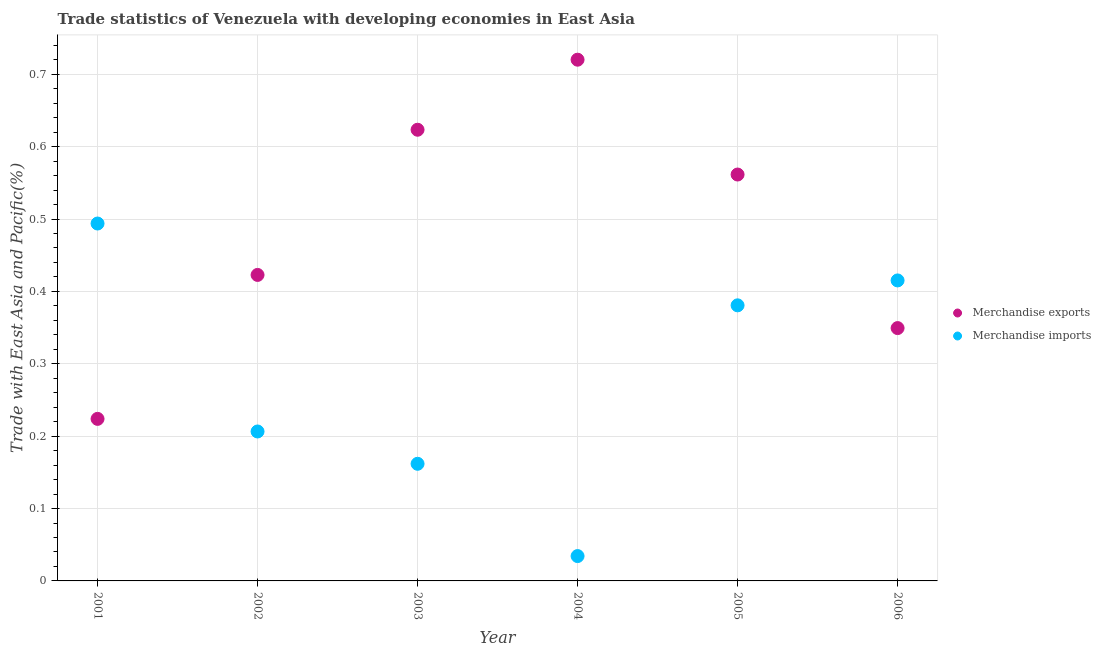Is the number of dotlines equal to the number of legend labels?
Ensure brevity in your answer.  Yes. What is the merchandise exports in 2004?
Offer a very short reply. 0.72. Across all years, what is the maximum merchandise imports?
Your answer should be compact. 0.49. Across all years, what is the minimum merchandise imports?
Provide a short and direct response. 0.03. In which year was the merchandise exports minimum?
Keep it short and to the point. 2001. What is the total merchandise exports in the graph?
Your answer should be compact. 2.9. What is the difference between the merchandise exports in 2002 and that in 2004?
Offer a terse response. -0.3. What is the difference between the merchandise exports in 2003 and the merchandise imports in 2006?
Ensure brevity in your answer.  0.21. What is the average merchandise exports per year?
Ensure brevity in your answer.  0.48. In the year 2002, what is the difference between the merchandise exports and merchandise imports?
Your answer should be very brief. 0.22. In how many years, is the merchandise imports greater than 0.16 %?
Your answer should be compact. 5. What is the ratio of the merchandise imports in 2001 to that in 2005?
Offer a very short reply. 1.3. Is the merchandise imports in 2002 less than that in 2006?
Provide a short and direct response. Yes. Is the difference between the merchandise exports in 2004 and 2005 greater than the difference between the merchandise imports in 2004 and 2005?
Keep it short and to the point. Yes. What is the difference between the highest and the second highest merchandise exports?
Offer a very short reply. 0.1. What is the difference between the highest and the lowest merchandise exports?
Your response must be concise. 0.5. Is the sum of the merchandise exports in 2002 and 2003 greater than the maximum merchandise imports across all years?
Ensure brevity in your answer.  Yes. Is the merchandise exports strictly less than the merchandise imports over the years?
Offer a very short reply. No. How many dotlines are there?
Give a very brief answer. 2. What is the difference between two consecutive major ticks on the Y-axis?
Your answer should be compact. 0.1. Are the values on the major ticks of Y-axis written in scientific E-notation?
Provide a succinct answer. No. How are the legend labels stacked?
Provide a succinct answer. Vertical. What is the title of the graph?
Offer a terse response. Trade statistics of Venezuela with developing economies in East Asia. What is the label or title of the Y-axis?
Provide a short and direct response. Trade with East Asia and Pacific(%). What is the Trade with East Asia and Pacific(%) in Merchandise exports in 2001?
Provide a succinct answer. 0.22. What is the Trade with East Asia and Pacific(%) of Merchandise imports in 2001?
Make the answer very short. 0.49. What is the Trade with East Asia and Pacific(%) of Merchandise exports in 2002?
Keep it short and to the point. 0.42. What is the Trade with East Asia and Pacific(%) in Merchandise imports in 2002?
Give a very brief answer. 0.21. What is the Trade with East Asia and Pacific(%) in Merchandise exports in 2003?
Your answer should be compact. 0.62. What is the Trade with East Asia and Pacific(%) of Merchandise imports in 2003?
Ensure brevity in your answer.  0.16. What is the Trade with East Asia and Pacific(%) of Merchandise exports in 2004?
Your answer should be compact. 0.72. What is the Trade with East Asia and Pacific(%) of Merchandise imports in 2004?
Your answer should be very brief. 0.03. What is the Trade with East Asia and Pacific(%) in Merchandise exports in 2005?
Keep it short and to the point. 0.56. What is the Trade with East Asia and Pacific(%) in Merchandise imports in 2005?
Your response must be concise. 0.38. What is the Trade with East Asia and Pacific(%) of Merchandise exports in 2006?
Your response must be concise. 0.35. What is the Trade with East Asia and Pacific(%) in Merchandise imports in 2006?
Offer a very short reply. 0.42. Across all years, what is the maximum Trade with East Asia and Pacific(%) of Merchandise exports?
Provide a short and direct response. 0.72. Across all years, what is the maximum Trade with East Asia and Pacific(%) of Merchandise imports?
Offer a very short reply. 0.49. Across all years, what is the minimum Trade with East Asia and Pacific(%) in Merchandise exports?
Your answer should be compact. 0.22. Across all years, what is the minimum Trade with East Asia and Pacific(%) of Merchandise imports?
Offer a terse response. 0.03. What is the total Trade with East Asia and Pacific(%) of Merchandise exports in the graph?
Offer a very short reply. 2.9. What is the total Trade with East Asia and Pacific(%) in Merchandise imports in the graph?
Make the answer very short. 1.69. What is the difference between the Trade with East Asia and Pacific(%) in Merchandise exports in 2001 and that in 2002?
Give a very brief answer. -0.2. What is the difference between the Trade with East Asia and Pacific(%) in Merchandise imports in 2001 and that in 2002?
Your response must be concise. 0.29. What is the difference between the Trade with East Asia and Pacific(%) of Merchandise exports in 2001 and that in 2003?
Ensure brevity in your answer.  -0.4. What is the difference between the Trade with East Asia and Pacific(%) in Merchandise imports in 2001 and that in 2003?
Make the answer very short. 0.33. What is the difference between the Trade with East Asia and Pacific(%) in Merchandise exports in 2001 and that in 2004?
Offer a terse response. -0.5. What is the difference between the Trade with East Asia and Pacific(%) in Merchandise imports in 2001 and that in 2004?
Your answer should be compact. 0.46. What is the difference between the Trade with East Asia and Pacific(%) in Merchandise exports in 2001 and that in 2005?
Keep it short and to the point. -0.34. What is the difference between the Trade with East Asia and Pacific(%) of Merchandise imports in 2001 and that in 2005?
Ensure brevity in your answer.  0.11. What is the difference between the Trade with East Asia and Pacific(%) in Merchandise exports in 2001 and that in 2006?
Keep it short and to the point. -0.13. What is the difference between the Trade with East Asia and Pacific(%) in Merchandise imports in 2001 and that in 2006?
Offer a terse response. 0.08. What is the difference between the Trade with East Asia and Pacific(%) in Merchandise exports in 2002 and that in 2003?
Provide a succinct answer. -0.2. What is the difference between the Trade with East Asia and Pacific(%) in Merchandise imports in 2002 and that in 2003?
Give a very brief answer. 0.04. What is the difference between the Trade with East Asia and Pacific(%) of Merchandise exports in 2002 and that in 2004?
Keep it short and to the point. -0.3. What is the difference between the Trade with East Asia and Pacific(%) of Merchandise imports in 2002 and that in 2004?
Your answer should be very brief. 0.17. What is the difference between the Trade with East Asia and Pacific(%) in Merchandise exports in 2002 and that in 2005?
Offer a terse response. -0.14. What is the difference between the Trade with East Asia and Pacific(%) of Merchandise imports in 2002 and that in 2005?
Keep it short and to the point. -0.17. What is the difference between the Trade with East Asia and Pacific(%) of Merchandise exports in 2002 and that in 2006?
Make the answer very short. 0.07. What is the difference between the Trade with East Asia and Pacific(%) in Merchandise imports in 2002 and that in 2006?
Offer a terse response. -0.21. What is the difference between the Trade with East Asia and Pacific(%) of Merchandise exports in 2003 and that in 2004?
Your response must be concise. -0.1. What is the difference between the Trade with East Asia and Pacific(%) of Merchandise imports in 2003 and that in 2004?
Your answer should be very brief. 0.13. What is the difference between the Trade with East Asia and Pacific(%) in Merchandise exports in 2003 and that in 2005?
Ensure brevity in your answer.  0.06. What is the difference between the Trade with East Asia and Pacific(%) in Merchandise imports in 2003 and that in 2005?
Make the answer very short. -0.22. What is the difference between the Trade with East Asia and Pacific(%) of Merchandise exports in 2003 and that in 2006?
Ensure brevity in your answer.  0.27. What is the difference between the Trade with East Asia and Pacific(%) of Merchandise imports in 2003 and that in 2006?
Make the answer very short. -0.25. What is the difference between the Trade with East Asia and Pacific(%) in Merchandise exports in 2004 and that in 2005?
Offer a terse response. 0.16. What is the difference between the Trade with East Asia and Pacific(%) in Merchandise imports in 2004 and that in 2005?
Give a very brief answer. -0.35. What is the difference between the Trade with East Asia and Pacific(%) of Merchandise exports in 2004 and that in 2006?
Ensure brevity in your answer.  0.37. What is the difference between the Trade with East Asia and Pacific(%) in Merchandise imports in 2004 and that in 2006?
Your answer should be compact. -0.38. What is the difference between the Trade with East Asia and Pacific(%) in Merchandise exports in 2005 and that in 2006?
Ensure brevity in your answer.  0.21. What is the difference between the Trade with East Asia and Pacific(%) of Merchandise imports in 2005 and that in 2006?
Your answer should be compact. -0.03. What is the difference between the Trade with East Asia and Pacific(%) in Merchandise exports in 2001 and the Trade with East Asia and Pacific(%) in Merchandise imports in 2002?
Give a very brief answer. 0.02. What is the difference between the Trade with East Asia and Pacific(%) of Merchandise exports in 2001 and the Trade with East Asia and Pacific(%) of Merchandise imports in 2003?
Offer a terse response. 0.06. What is the difference between the Trade with East Asia and Pacific(%) in Merchandise exports in 2001 and the Trade with East Asia and Pacific(%) in Merchandise imports in 2004?
Your response must be concise. 0.19. What is the difference between the Trade with East Asia and Pacific(%) of Merchandise exports in 2001 and the Trade with East Asia and Pacific(%) of Merchandise imports in 2005?
Keep it short and to the point. -0.16. What is the difference between the Trade with East Asia and Pacific(%) in Merchandise exports in 2001 and the Trade with East Asia and Pacific(%) in Merchandise imports in 2006?
Give a very brief answer. -0.19. What is the difference between the Trade with East Asia and Pacific(%) in Merchandise exports in 2002 and the Trade with East Asia and Pacific(%) in Merchandise imports in 2003?
Make the answer very short. 0.26. What is the difference between the Trade with East Asia and Pacific(%) of Merchandise exports in 2002 and the Trade with East Asia and Pacific(%) of Merchandise imports in 2004?
Ensure brevity in your answer.  0.39. What is the difference between the Trade with East Asia and Pacific(%) of Merchandise exports in 2002 and the Trade with East Asia and Pacific(%) of Merchandise imports in 2005?
Your answer should be compact. 0.04. What is the difference between the Trade with East Asia and Pacific(%) of Merchandise exports in 2002 and the Trade with East Asia and Pacific(%) of Merchandise imports in 2006?
Your answer should be very brief. 0.01. What is the difference between the Trade with East Asia and Pacific(%) of Merchandise exports in 2003 and the Trade with East Asia and Pacific(%) of Merchandise imports in 2004?
Ensure brevity in your answer.  0.59. What is the difference between the Trade with East Asia and Pacific(%) in Merchandise exports in 2003 and the Trade with East Asia and Pacific(%) in Merchandise imports in 2005?
Offer a very short reply. 0.24. What is the difference between the Trade with East Asia and Pacific(%) in Merchandise exports in 2003 and the Trade with East Asia and Pacific(%) in Merchandise imports in 2006?
Ensure brevity in your answer.  0.21. What is the difference between the Trade with East Asia and Pacific(%) in Merchandise exports in 2004 and the Trade with East Asia and Pacific(%) in Merchandise imports in 2005?
Your response must be concise. 0.34. What is the difference between the Trade with East Asia and Pacific(%) of Merchandise exports in 2004 and the Trade with East Asia and Pacific(%) of Merchandise imports in 2006?
Give a very brief answer. 0.3. What is the difference between the Trade with East Asia and Pacific(%) in Merchandise exports in 2005 and the Trade with East Asia and Pacific(%) in Merchandise imports in 2006?
Your response must be concise. 0.15. What is the average Trade with East Asia and Pacific(%) in Merchandise exports per year?
Ensure brevity in your answer.  0.48. What is the average Trade with East Asia and Pacific(%) of Merchandise imports per year?
Offer a terse response. 0.28. In the year 2001, what is the difference between the Trade with East Asia and Pacific(%) of Merchandise exports and Trade with East Asia and Pacific(%) of Merchandise imports?
Provide a short and direct response. -0.27. In the year 2002, what is the difference between the Trade with East Asia and Pacific(%) of Merchandise exports and Trade with East Asia and Pacific(%) of Merchandise imports?
Your response must be concise. 0.22. In the year 2003, what is the difference between the Trade with East Asia and Pacific(%) of Merchandise exports and Trade with East Asia and Pacific(%) of Merchandise imports?
Offer a very short reply. 0.46. In the year 2004, what is the difference between the Trade with East Asia and Pacific(%) of Merchandise exports and Trade with East Asia and Pacific(%) of Merchandise imports?
Your answer should be compact. 0.69. In the year 2005, what is the difference between the Trade with East Asia and Pacific(%) of Merchandise exports and Trade with East Asia and Pacific(%) of Merchandise imports?
Provide a succinct answer. 0.18. In the year 2006, what is the difference between the Trade with East Asia and Pacific(%) in Merchandise exports and Trade with East Asia and Pacific(%) in Merchandise imports?
Provide a succinct answer. -0.07. What is the ratio of the Trade with East Asia and Pacific(%) in Merchandise exports in 2001 to that in 2002?
Ensure brevity in your answer.  0.53. What is the ratio of the Trade with East Asia and Pacific(%) in Merchandise imports in 2001 to that in 2002?
Keep it short and to the point. 2.39. What is the ratio of the Trade with East Asia and Pacific(%) of Merchandise exports in 2001 to that in 2003?
Offer a terse response. 0.36. What is the ratio of the Trade with East Asia and Pacific(%) in Merchandise imports in 2001 to that in 2003?
Your response must be concise. 3.05. What is the ratio of the Trade with East Asia and Pacific(%) in Merchandise exports in 2001 to that in 2004?
Provide a succinct answer. 0.31. What is the ratio of the Trade with East Asia and Pacific(%) in Merchandise imports in 2001 to that in 2004?
Your response must be concise. 14.38. What is the ratio of the Trade with East Asia and Pacific(%) in Merchandise exports in 2001 to that in 2005?
Your answer should be compact. 0.4. What is the ratio of the Trade with East Asia and Pacific(%) in Merchandise imports in 2001 to that in 2005?
Offer a very short reply. 1.3. What is the ratio of the Trade with East Asia and Pacific(%) in Merchandise exports in 2001 to that in 2006?
Ensure brevity in your answer.  0.64. What is the ratio of the Trade with East Asia and Pacific(%) in Merchandise imports in 2001 to that in 2006?
Provide a succinct answer. 1.19. What is the ratio of the Trade with East Asia and Pacific(%) in Merchandise exports in 2002 to that in 2003?
Your answer should be compact. 0.68. What is the ratio of the Trade with East Asia and Pacific(%) of Merchandise imports in 2002 to that in 2003?
Ensure brevity in your answer.  1.28. What is the ratio of the Trade with East Asia and Pacific(%) in Merchandise exports in 2002 to that in 2004?
Offer a very short reply. 0.59. What is the ratio of the Trade with East Asia and Pacific(%) of Merchandise imports in 2002 to that in 2004?
Provide a short and direct response. 6.01. What is the ratio of the Trade with East Asia and Pacific(%) of Merchandise exports in 2002 to that in 2005?
Offer a very short reply. 0.75. What is the ratio of the Trade with East Asia and Pacific(%) of Merchandise imports in 2002 to that in 2005?
Your answer should be compact. 0.54. What is the ratio of the Trade with East Asia and Pacific(%) of Merchandise exports in 2002 to that in 2006?
Keep it short and to the point. 1.21. What is the ratio of the Trade with East Asia and Pacific(%) in Merchandise imports in 2002 to that in 2006?
Make the answer very short. 0.5. What is the ratio of the Trade with East Asia and Pacific(%) in Merchandise exports in 2003 to that in 2004?
Provide a succinct answer. 0.87. What is the ratio of the Trade with East Asia and Pacific(%) of Merchandise imports in 2003 to that in 2004?
Your answer should be compact. 4.71. What is the ratio of the Trade with East Asia and Pacific(%) in Merchandise exports in 2003 to that in 2005?
Give a very brief answer. 1.11. What is the ratio of the Trade with East Asia and Pacific(%) of Merchandise imports in 2003 to that in 2005?
Make the answer very short. 0.42. What is the ratio of the Trade with East Asia and Pacific(%) in Merchandise exports in 2003 to that in 2006?
Offer a very short reply. 1.78. What is the ratio of the Trade with East Asia and Pacific(%) of Merchandise imports in 2003 to that in 2006?
Ensure brevity in your answer.  0.39. What is the ratio of the Trade with East Asia and Pacific(%) of Merchandise exports in 2004 to that in 2005?
Your answer should be compact. 1.28. What is the ratio of the Trade with East Asia and Pacific(%) in Merchandise imports in 2004 to that in 2005?
Give a very brief answer. 0.09. What is the ratio of the Trade with East Asia and Pacific(%) in Merchandise exports in 2004 to that in 2006?
Give a very brief answer. 2.06. What is the ratio of the Trade with East Asia and Pacific(%) of Merchandise imports in 2004 to that in 2006?
Your answer should be compact. 0.08. What is the ratio of the Trade with East Asia and Pacific(%) in Merchandise exports in 2005 to that in 2006?
Your answer should be very brief. 1.61. What is the ratio of the Trade with East Asia and Pacific(%) of Merchandise imports in 2005 to that in 2006?
Your response must be concise. 0.92. What is the difference between the highest and the second highest Trade with East Asia and Pacific(%) of Merchandise exports?
Ensure brevity in your answer.  0.1. What is the difference between the highest and the second highest Trade with East Asia and Pacific(%) in Merchandise imports?
Your answer should be very brief. 0.08. What is the difference between the highest and the lowest Trade with East Asia and Pacific(%) of Merchandise exports?
Make the answer very short. 0.5. What is the difference between the highest and the lowest Trade with East Asia and Pacific(%) in Merchandise imports?
Provide a short and direct response. 0.46. 